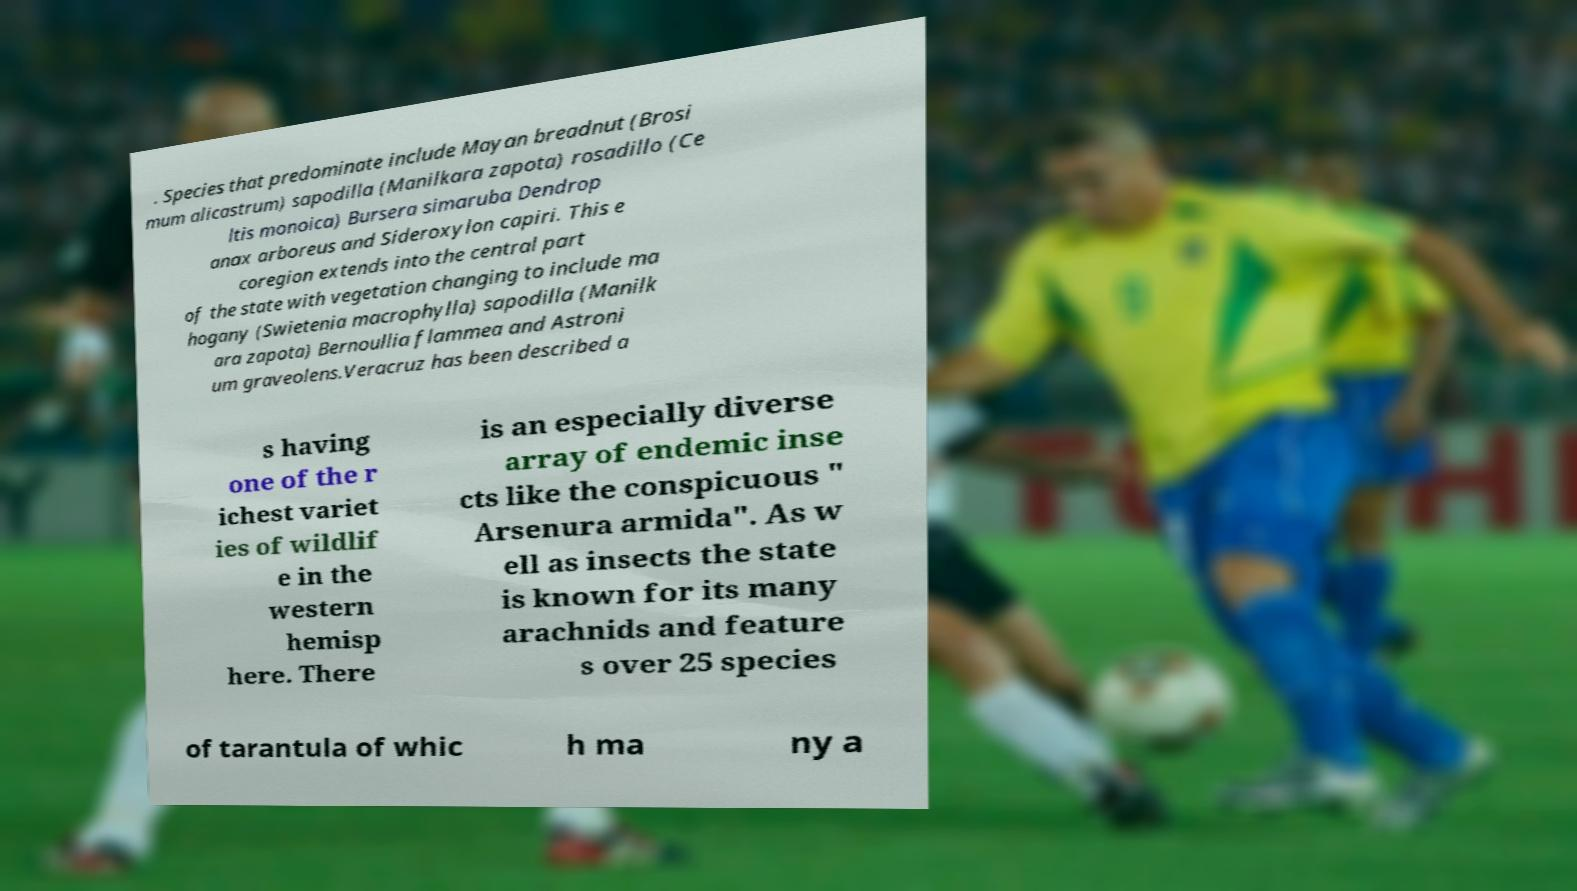For documentation purposes, I need the text within this image transcribed. Could you provide that? . Species that predominate include Mayan breadnut (Brosi mum alicastrum) sapodilla (Manilkara zapota) rosadillo (Ce ltis monoica) Bursera simaruba Dendrop anax arboreus and Sideroxylon capiri. This e coregion extends into the central part of the state with vegetation changing to include ma hogany (Swietenia macrophylla) sapodilla (Manilk ara zapota) Bernoullia flammea and Astroni um graveolens.Veracruz has been described a s having one of the r ichest variet ies of wildlif e in the western hemisp here. There is an especially diverse array of endemic inse cts like the conspicuous " Arsenura armida". As w ell as insects the state is known for its many arachnids and feature s over 25 species of tarantula of whic h ma ny a 